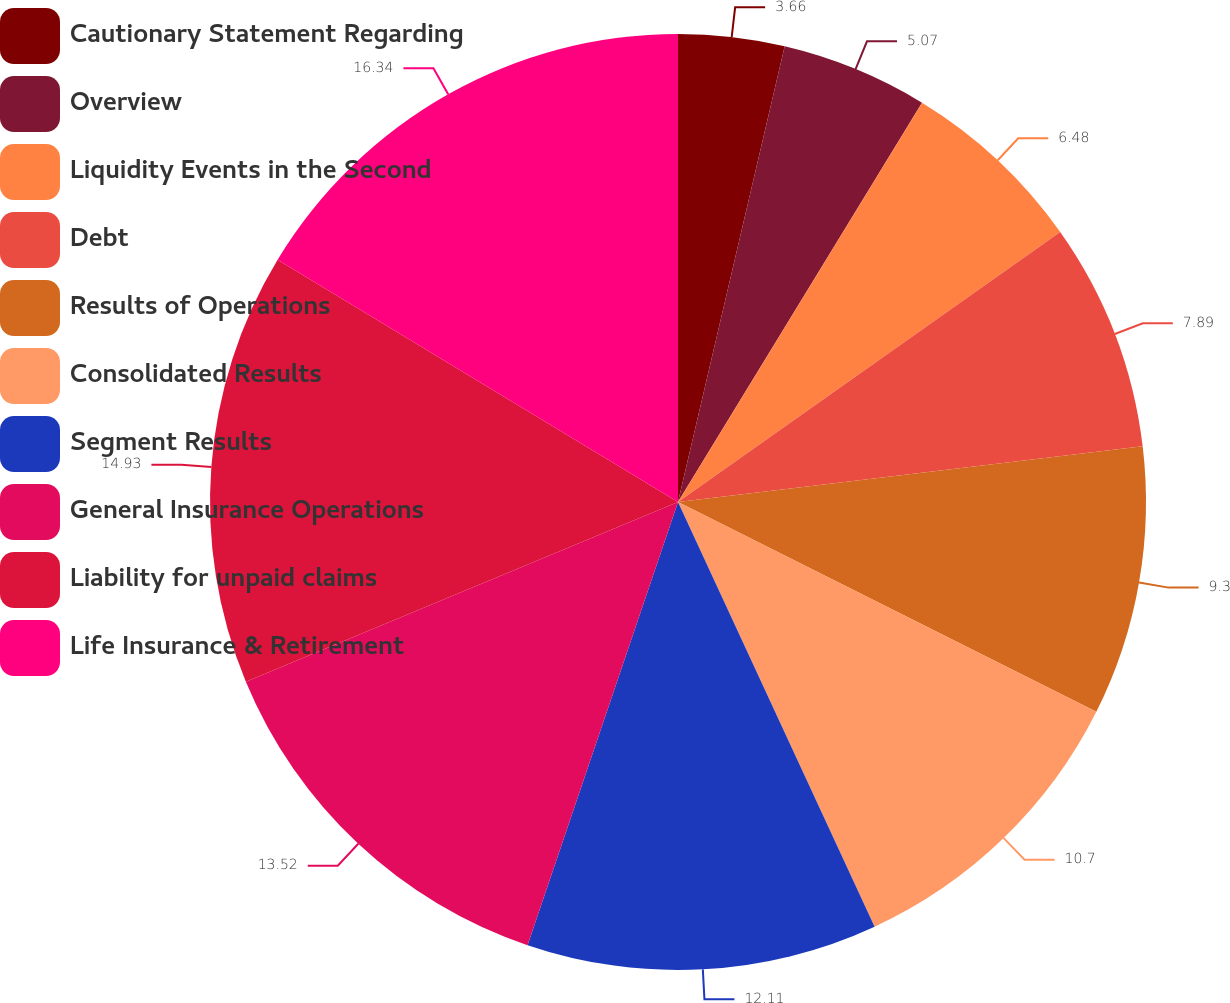<chart> <loc_0><loc_0><loc_500><loc_500><pie_chart><fcel>Cautionary Statement Regarding<fcel>Overview<fcel>Liquidity Events in the Second<fcel>Debt<fcel>Results of Operations<fcel>Consolidated Results<fcel>Segment Results<fcel>General Insurance Operations<fcel>Liability for unpaid claims<fcel>Life Insurance & Retirement<nl><fcel>3.66%<fcel>5.07%<fcel>6.48%<fcel>7.89%<fcel>9.3%<fcel>10.7%<fcel>12.11%<fcel>13.52%<fcel>14.93%<fcel>16.34%<nl></chart> 